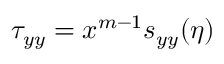Convert formula to latex. <formula><loc_0><loc_0><loc_500><loc_500>\tau _ { y y } = x ^ { m - 1 } s _ { y y } ( \eta )</formula> 